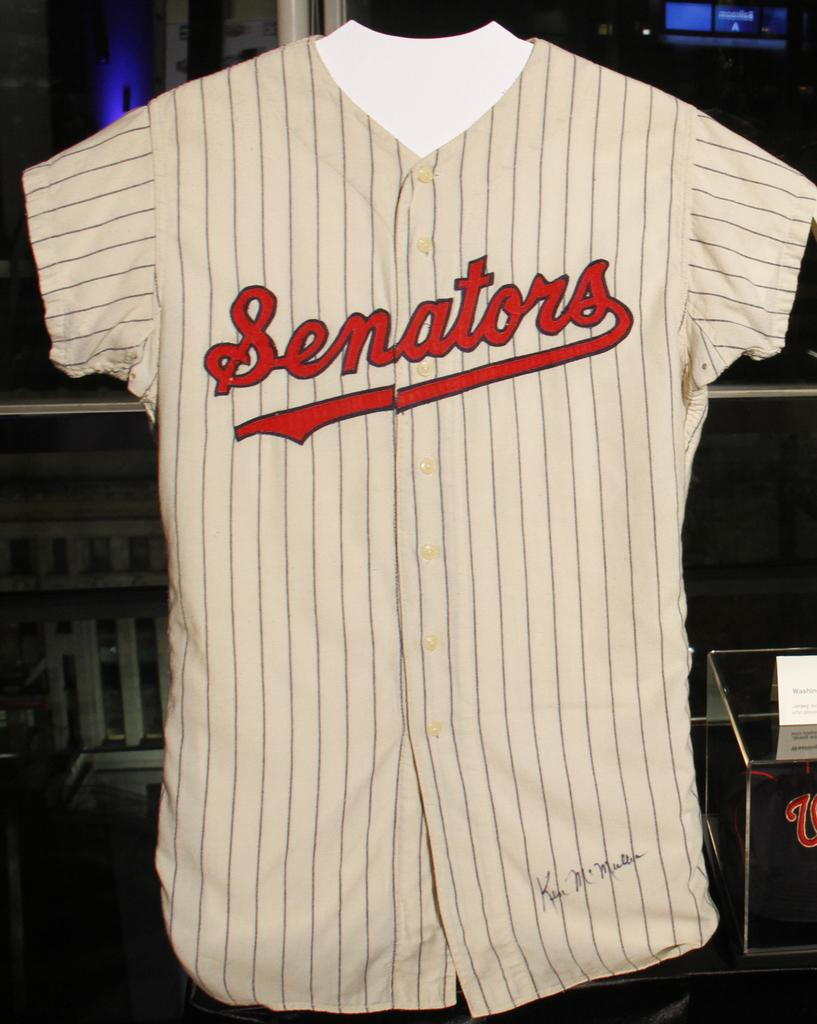<image>
Describe the image concisely. A jersey with Senators written across the front is on display 